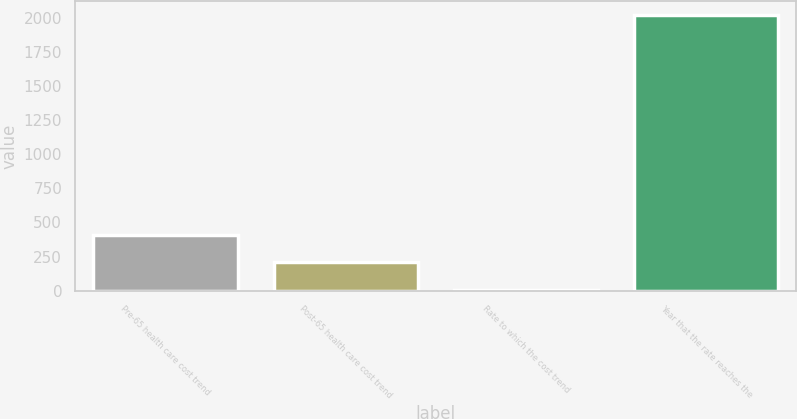Convert chart to OTSL. <chart><loc_0><loc_0><loc_500><loc_500><bar_chart><fcel>Pre-65 health care cost trend<fcel>Post-65 health care cost trend<fcel>Rate to which the cost trend<fcel>Year that the rate reaches the<nl><fcel>408.2<fcel>206.6<fcel>5<fcel>2021<nl></chart> 